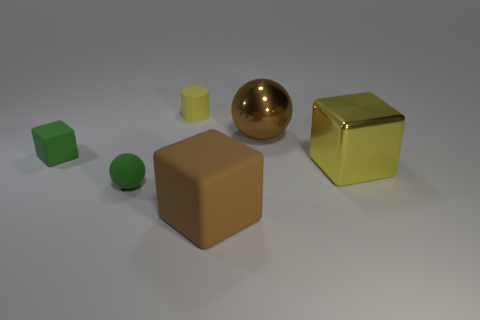Add 3 yellow metal cubes. How many objects exist? 9 Subtract all spheres. How many objects are left? 4 Subtract 1 green spheres. How many objects are left? 5 Subtract all big red cylinders. Subtract all rubber objects. How many objects are left? 2 Add 6 big rubber cubes. How many big rubber cubes are left? 7 Add 2 green things. How many green things exist? 4 